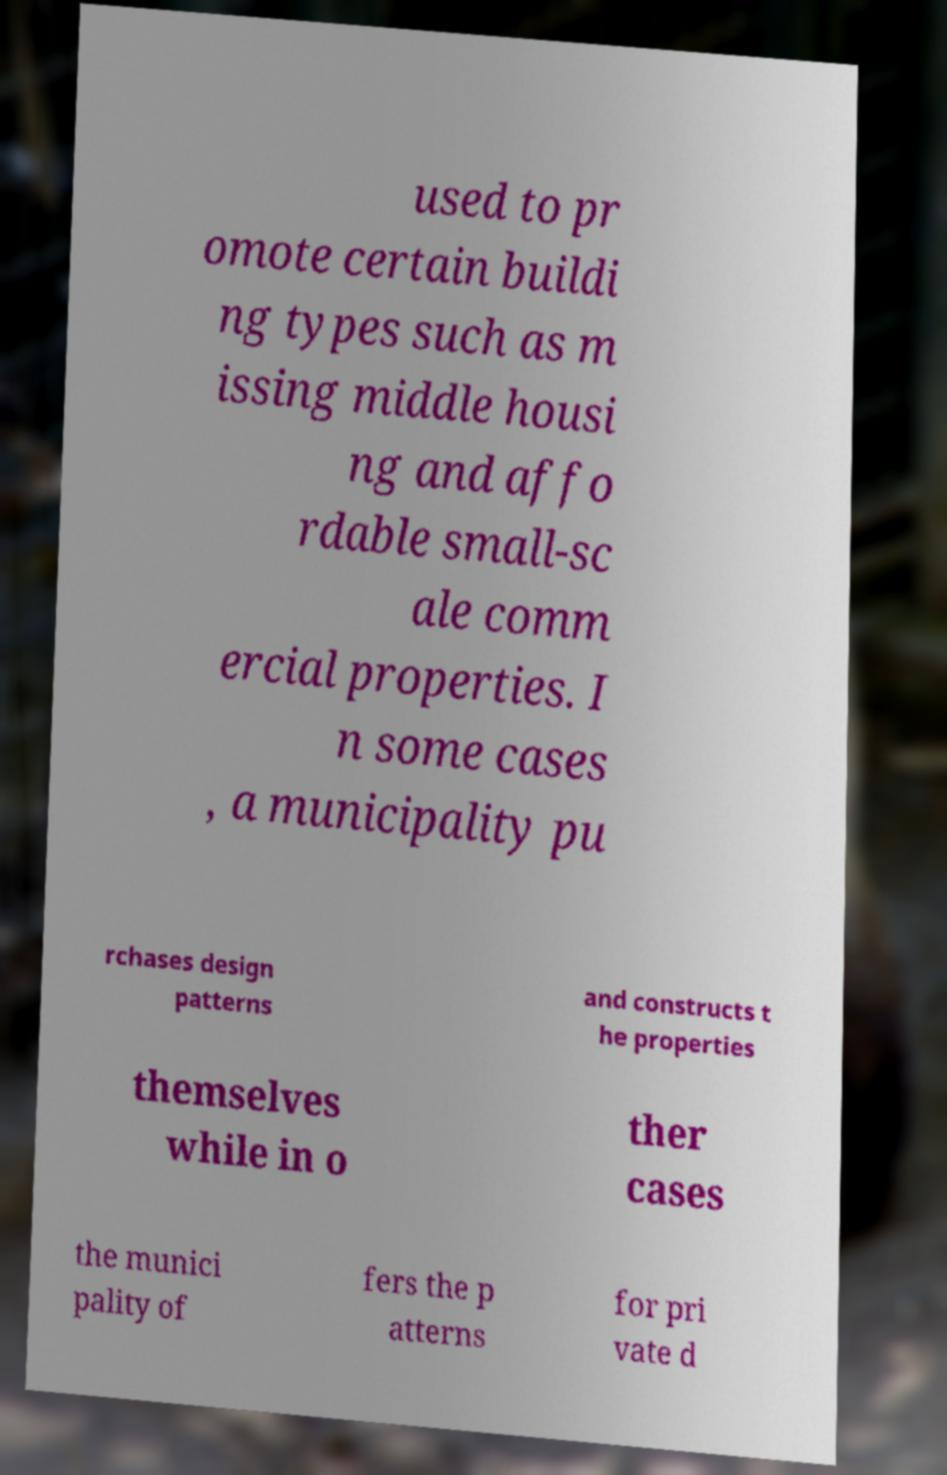Can you accurately transcribe the text from the provided image for me? used to pr omote certain buildi ng types such as m issing middle housi ng and affo rdable small-sc ale comm ercial properties. I n some cases , a municipality pu rchases design patterns and constructs t he properties themselves while in o ther cases the munici pality of fers the p atterns for pri vate d 